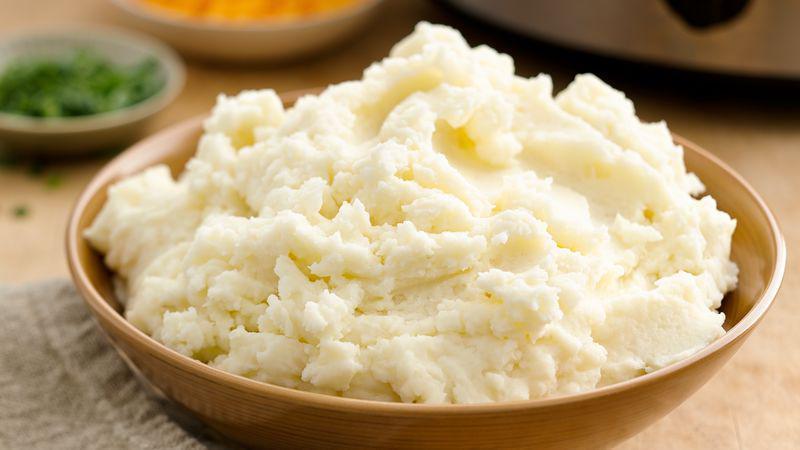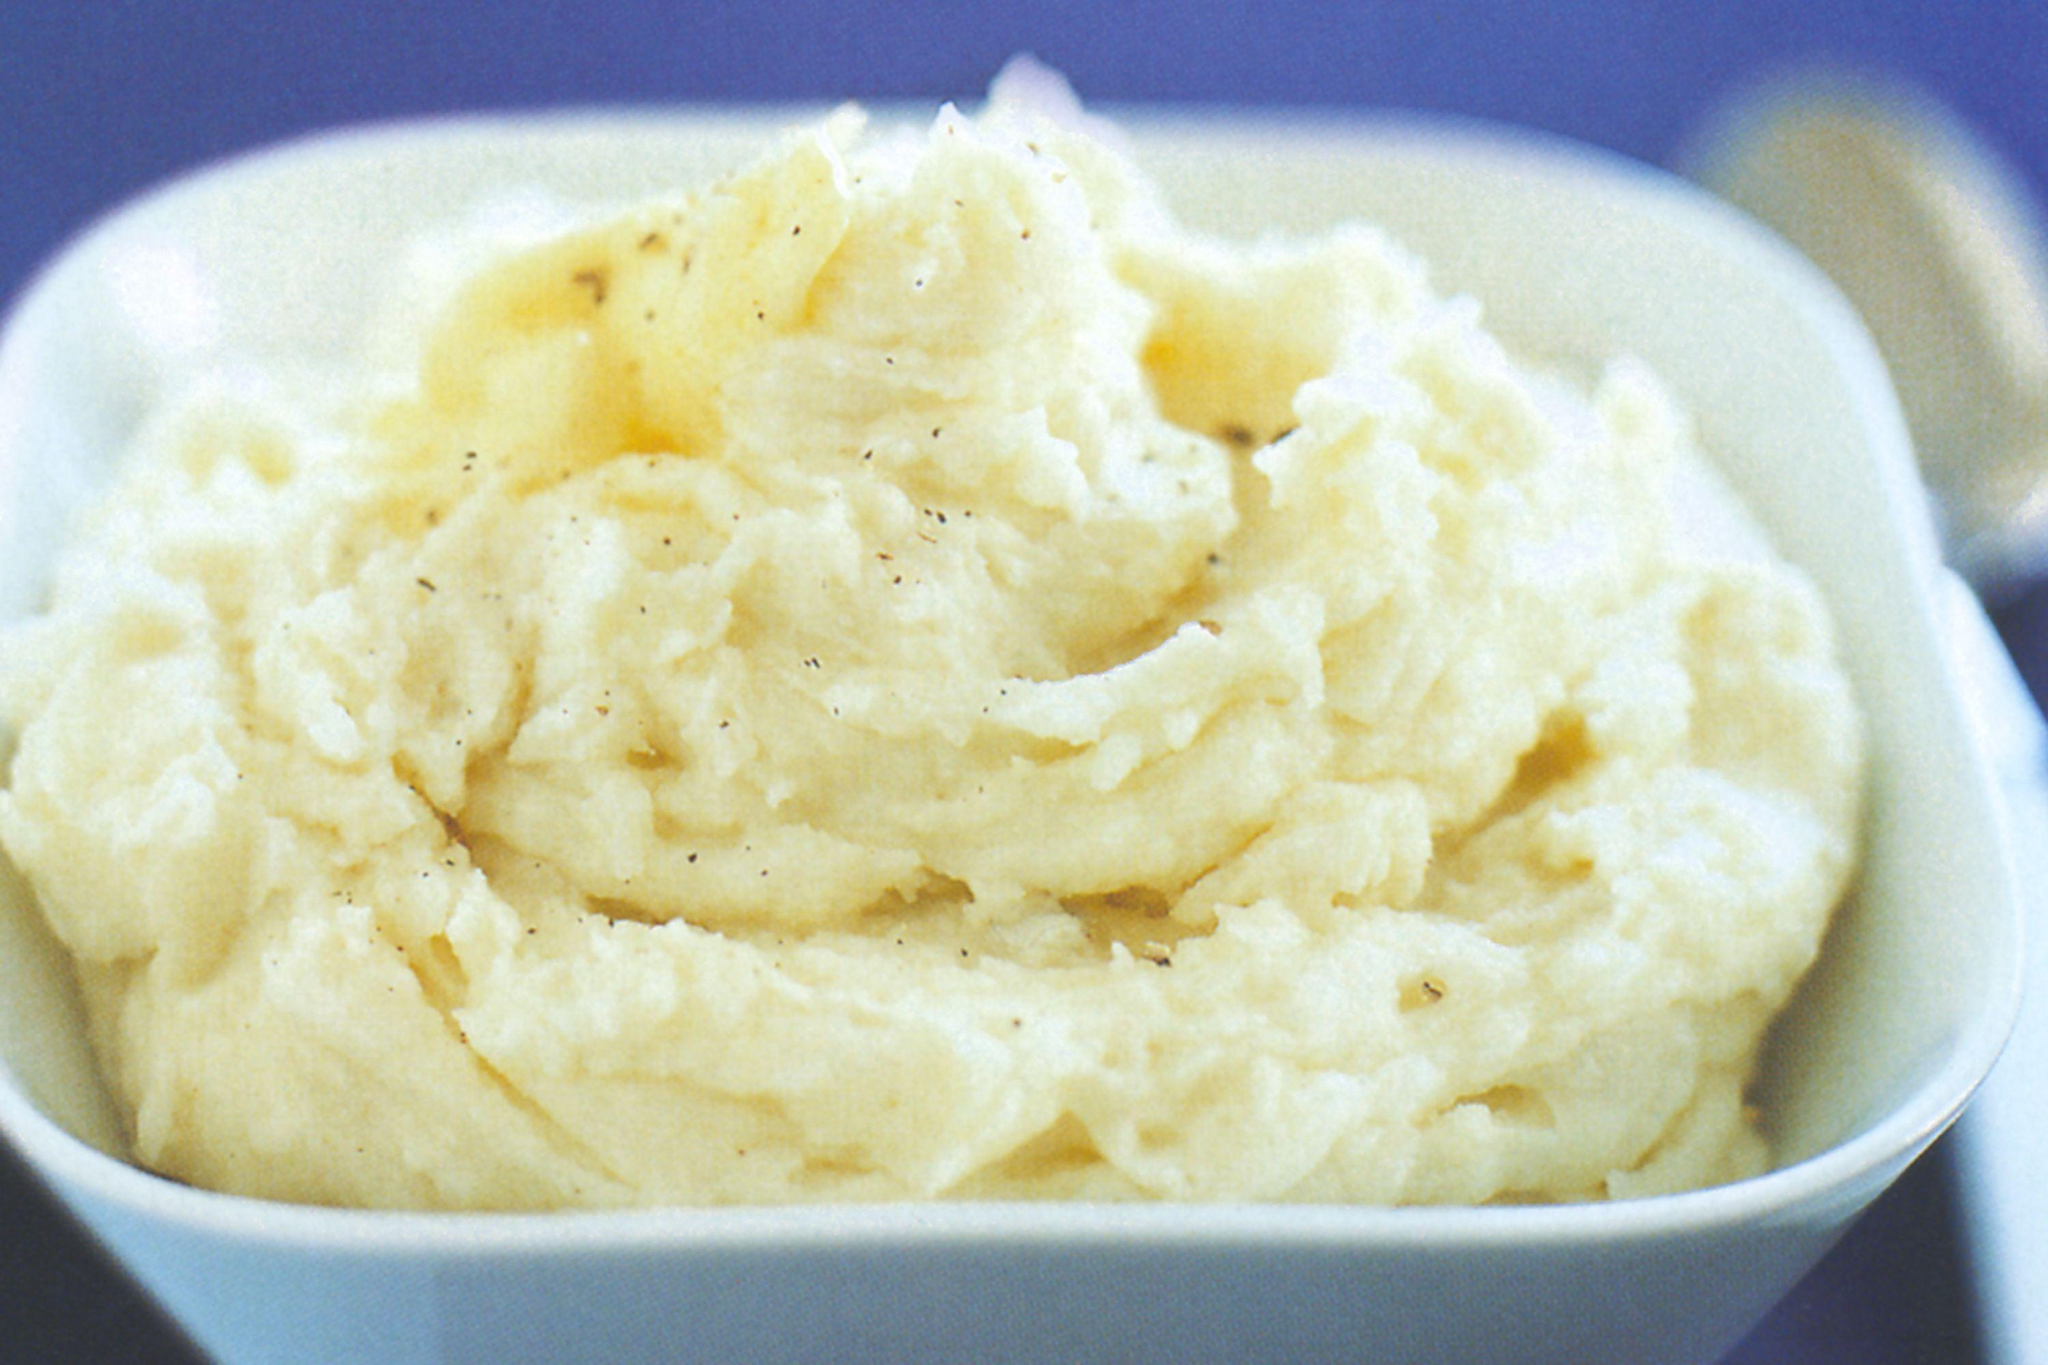The first image is the image on the left, the second image is the image on the right. Evaluate the accuracy of this statement regarding the images: "The potatoes in one of the images are served a grey bowl.". Is it true? Answer yes or no. No. The first image is the image on the left, the second image is the image on the right. For the images displayed, is the sentence "the mashed potato on the right image is on a white bowl." factually correct? Answer yes or no. Yes. The first image is the image on the left, the second image is the image on the right. For the images displayed, is the sentence "One bowl of potatoes is ungarnished, and the other is topped with a sprinkling of chopped green bits." factually correct? Answer yes or no. No. 